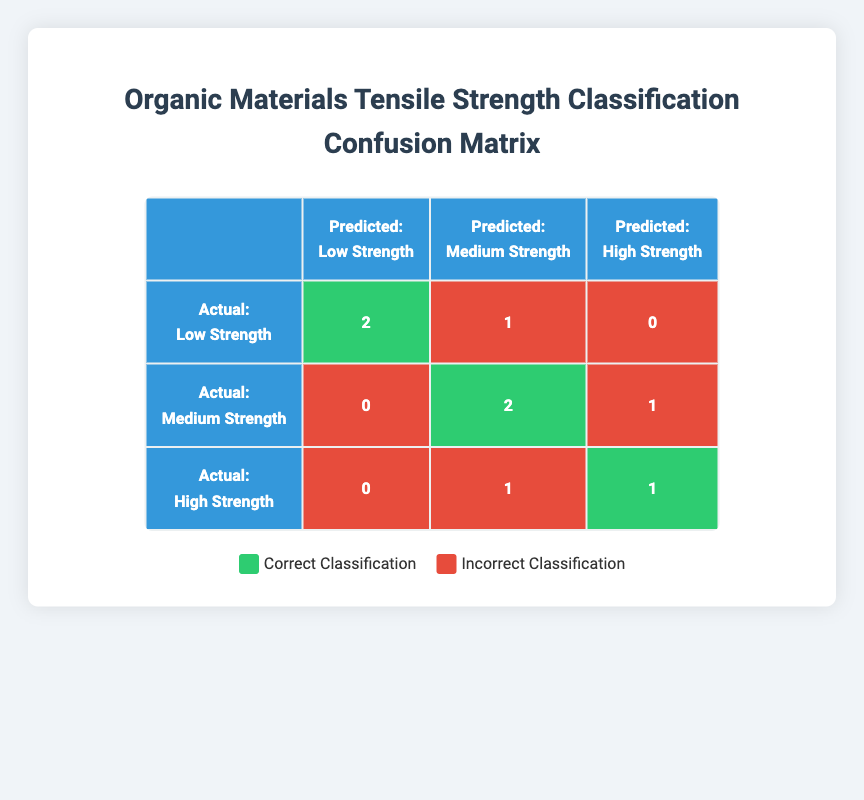What is the total number of materials classified as Low Strength? From the table, the actual class "Low Strength" has a count of 2 correctly classified (Polyethylene and Natural Rubber) and 1 incorrectly classified (Polystyrene), which gives a total of 3 materials in this class.
Answer: 3 How many materials were correctly predicted as High Strength? The table shows that there is 1 material (Polycarbonate) that was correctly classified as High Strength.
Answer: 1 What percentage of Medium Strength materials were classified correctly? There are 3 materials classified as Medium Strength (Nylon 6,6, Polypropylene, and Silicone), out of which 2 were classified correctly. To find the percentage: (2/3) * 100 = 66.67%.
Answer: 66.67% Is it true that Natural Rubber was both the correct actual and predicted class? Looking at the table, Natural Rubber has its actual class of Low Strength and is also predicted as Low Strength. This confirms that it was classified correctly.
Answer: Yes What is the total count of incorrect classifications across all tensile strength classes? By examining the table, the total incorrect classifications are: 1 (Polystyrene, Low Strength predicted as Medium), 1 (Epoxy Resin, High Strength predicted as Medium), 1 (Polypropylene, Medium Strength predicted as High), and 1 (Nylon 6,6, High Strength predicted as Medium), giving a total of 4 incorrect classifications.
Answer: 4 In terms of actual classifications, was the majority of the Medium Strength category predicted correctly? There are 3 actual Medium Strength materials, and 2 of them are correctly classified, which means the majority (more than 50%) were classified accurately.
Answer: Yes What is the sum of all correct classifications in the Low Strength and Medium Strength categories? In the Low Strength category, there are 2 correct classifications (Polyethylene and Natural Rubber). In the Medium Strength category, there are 2 correct classifications (Nylon 6,6 and Silicone). Summing these, 2 + 2 = 4.
Answer: 4 What is the difference between the number of correct classifications for Low Strength and High Strength? For Low Strength, there are 2 correct classifications, and for High Strength, there is 1 correct classification. Therefore, the difference is 2 - 1 = 1.
Answer: 1 What is the number of materials classified as Low Strength but were incorrectly predicted? Reviewing the table, there is only 1 material (Polystyrene) that was classified as Low Strength but was incorrectly predicted as Medium Strength.
Answer: 1 